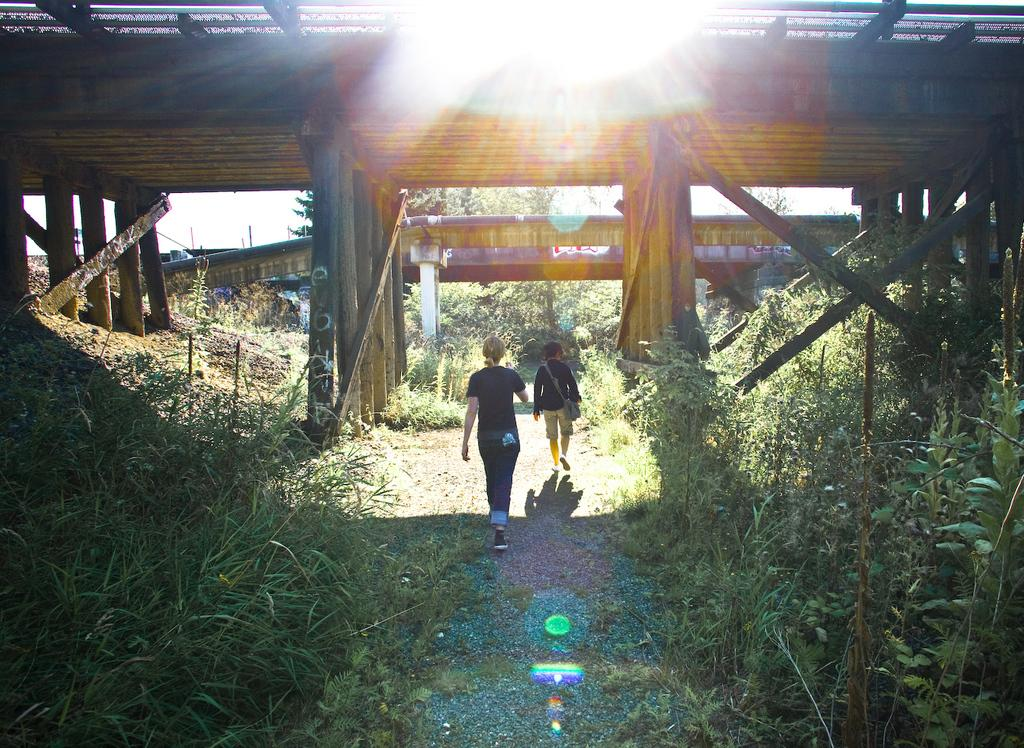How many people are walking in the image? There are two persons walking in the image. What surface are the persons walking on? The persons are walking on the ground. What type of vegetation can be seen in the image? There is grass and plants visible in the image. What structures can be seen in the background of the image? There are bridges in the background of the image. What else is visible in the background of the image? Trees and objects are present in the background of the image. What part of the natural environment is visible in the image? The sky is visible in the background of the image. What type of star can be seen in the image? There is no star visible in the image; it features two persons walking and a background with bridges, trees, and the sky. Are there any giants present in the image? There are no giants present in the image; it features two persons walking and a background with bridges, trees, and the sky. 